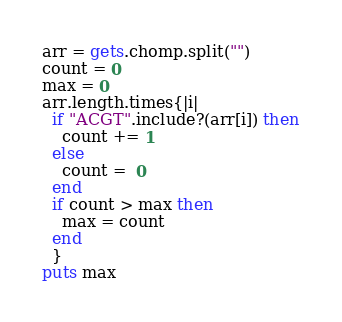<code> <loc_0><loc_0><loc_500><loc_500><_Ruby_>arr = gets.chomp.split("")
count = 0
max = 0
arr.length.times{|i|
  if "ACGT".include?(arr[i]) then
    count += 1
  else
    count =  0
  end
  if count > max then
    max = count
  end
  }
puts max</code> 